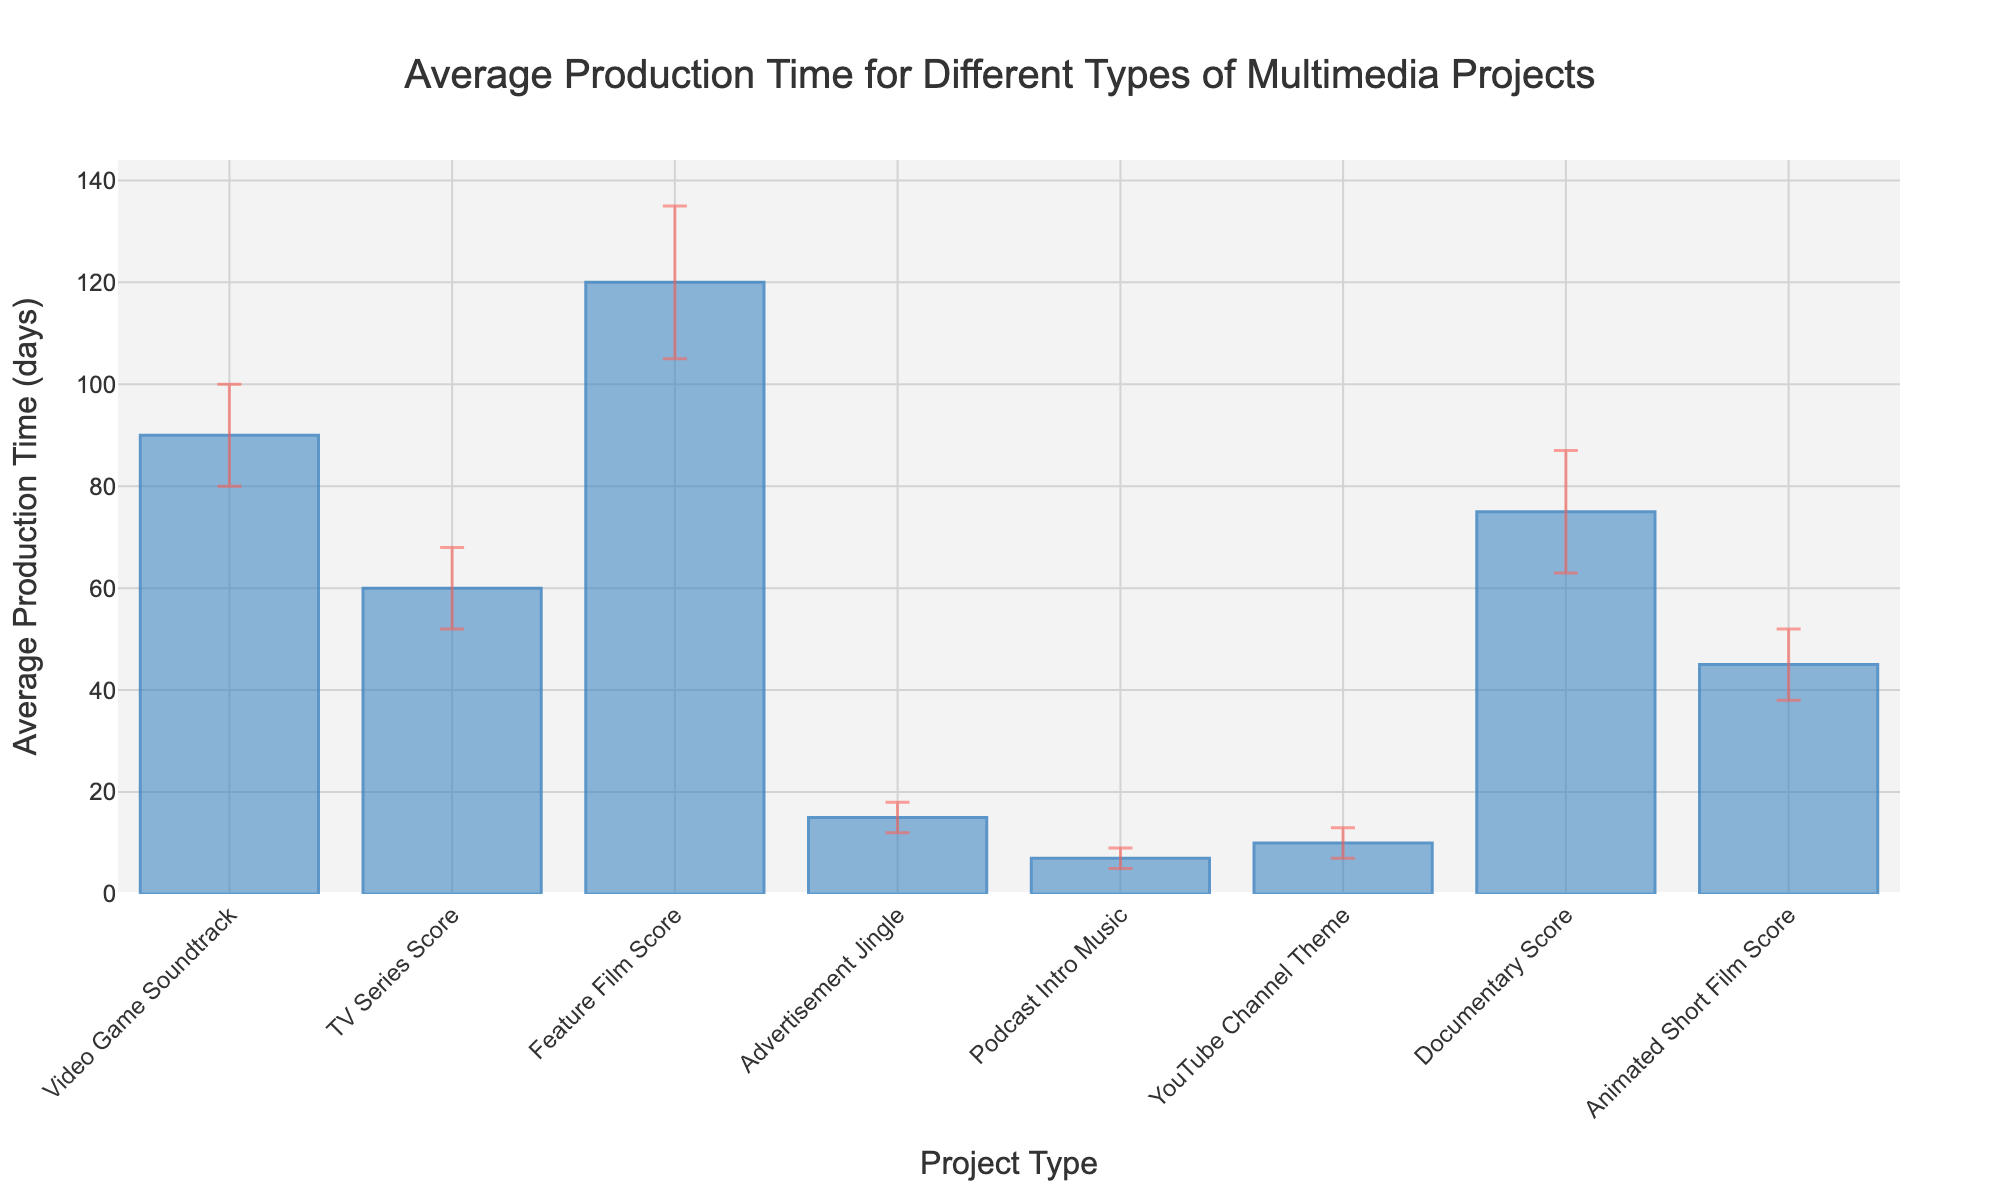What's the title of the bar chart? The title is usually displayed at the top center of the chart. It provides a quick overview of what the chart represents.
Answer: Average Production Time for Different Types of Multimedia Projects Which project type has the shortest average production time? Look for the shortest bar in the chart, indicating the lowest value on the y-axis.
Answer: Podcast Intro Music How much longer, on average, is the production time for a Feature Film Score compared to a TV Series Score? Subtract the average production time of the TV Series Score from the Feature Film Score (120 days - 60 days).
Answer: 60 days What is the error margin for the Documentary Score? Find the bar labeled "Documentary Score" and look at the length of the error bars extending from it.
Answer: 12 days How many project types have an average production time greater than 70 days? Count the bars whose heights are above the 70-day mark on the y-axis.
Answer: Three (Video Game Soundtrack, Feature Film Score, Documentary Score) Which project type has the highest error margin, and what is it? Identify the bar with the longest error bars extending from it by looking at the error bar lengths.
Answer: Feature Film Score: 15 days What's the difference in average production time between an Advertisement Jingle and a YouTube Channel Theme? Subtract the average production time of the YouTube Channel Theme from the Advertisement Jingle (15 days - 10 days).
Answer: 5 days What is the total average production time for Podcast Intro Music, YouTube Channel Theme, and Animated Short Film Score? Add up the average production times for these three project types (7 days + 10 days + 45 days).
Answer: 62 days Which project type has an average production time closest to 50 days, and what is the exact value? Find the bar whose height is nearest to the 50-day mark on the y-axis.
Answer: Animated Short Film Score: 45 days 